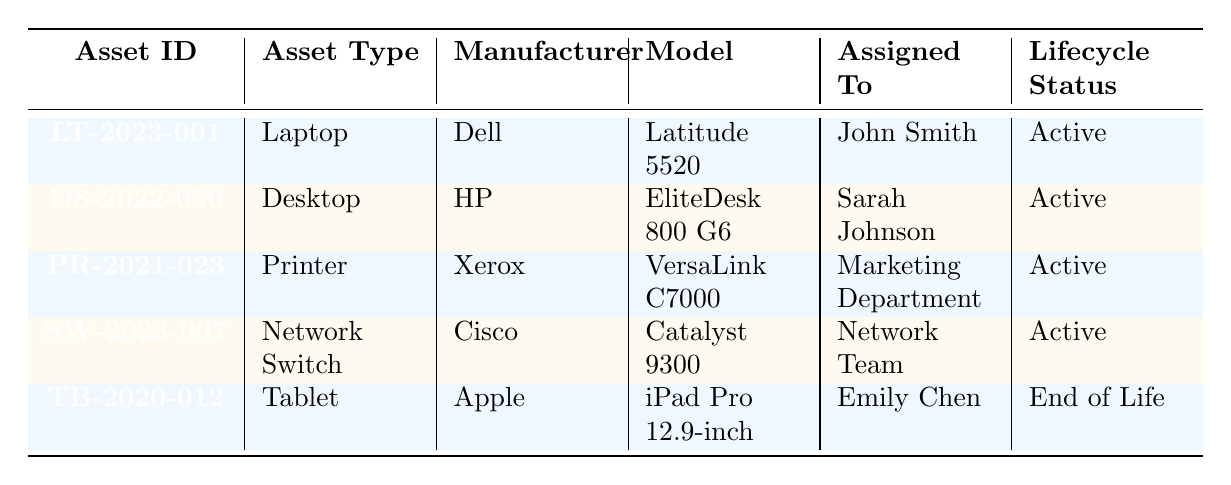What is the Asset ID of the Desktop? To find the Asset ID of the Desktop, we look for the asset type "Desktop" in the table. The corresponding Asset ID is "DS-2022-056."
Answer: DS-2022-056 Which department is assigned to the Laptop asset? The Laptop asset is associated with "John Smith," and upon checking the department column, it is listed under the "IT" department.
Answer: IT How many assets have a warranty expiration date in the year 2025? We examine each asset's warranty expiration date. The Desktop (2025), and the Printer (2024) fulfill the year requirement. Thus, only one asset satisfies this condition.
Answer: 1 Is the iPad Pro still under warranty? The iPad Pro has a warranty expiration date of "2022-06-19." Since the current date is beyond this date, it is no longer under warranty.
Answer: No Which asset has the latest next scheduled maintenance date? The next scheduled maintenance dates are compared: for the Laptop it is "2023-06-30," for the Desktop it is "2023-09-15," and the others are "2023-05-31" and "2023-07-05." The Desktop (2023-09-15) has the latest date.
Answer: DS-2022-056 What is the lifecycle status of the Tablet? The lifecycle status for the Tablet is directly listed in the table and is noted as "End of Life."
Answer: End of Life How many different types of assets are listed? Review the asset type column: Laptop, Desktop, Printer, Network Switch, and Tablet, leading to a total of 5 distinct asset types.
Answer: 5 What is the gap between the purchase date and planned retirement date of the Printer? The purchase date for the Printer is "2021-11-10," and the planned retirement date is "2026-11-10." The gap between these dates is 5 years.
Answer: 5 years Are any assets assigned to the Marketing department? By scanning the assigned department, we see the Printer asset is assigned to the "Marketing Department." Therefore, there is an asset assigned to Marketing.
Answer: Yes Which asset has the earliest purchase date? Comparing all purchase dates, the Tablet has the earliest purchase date of "2020-06-20."
Answer: TB-2020-012 